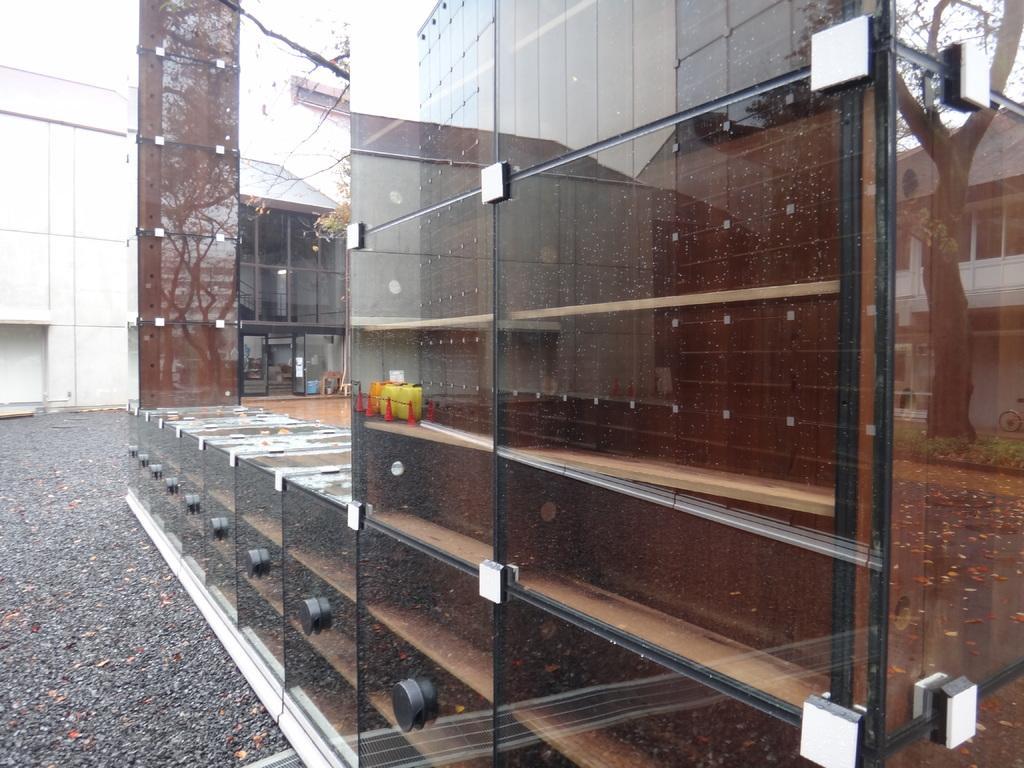How would you summarize this image in a sentence or two? In this picture we can see buildings. On the right side of the picture we can see the reflection of objects, a building, tree, a bicycle on the glass. At the bottom we can see dried leaves on the road. 